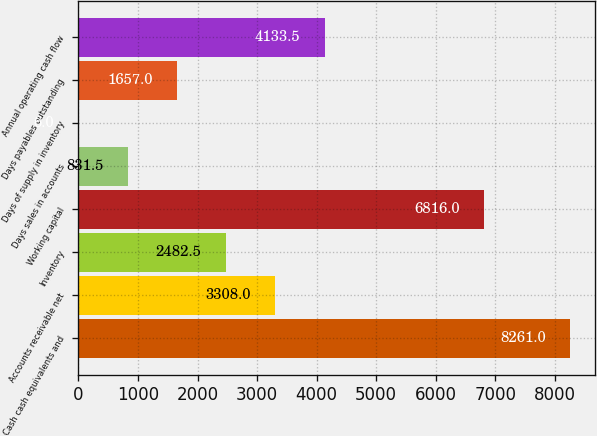<chart> <loc_0><loc_0><loc_500><loc_500><bar_chart><fcel>Cash cash equivalents and<fcel>Accounts receivable net<fcel>Inventory<fcel>Working capital<fcel>Days sales in accounts<fcel>Days of supply in inventory<fcel>Days payables outstanding<fcel>Annual operating cash flow<nl><fcel>8261<fcel>3308<fcel>2482.5<fcel>6816<fcel>831.5<fcel>6<fcel>1657<fcel>4133.5<nl></chart> 